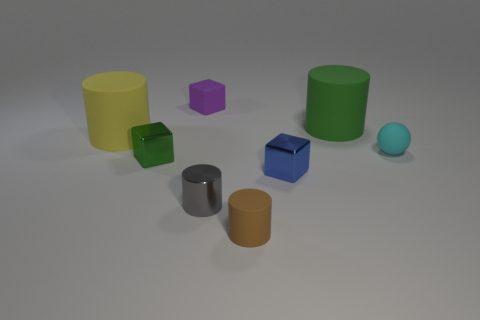There is a large object that is on the left side of the tiny matte thing that is behind the big green cylinder; what is its shape?
Keep it short and to the point. Cylinder. The green matte thing is what size?
Make the answer very short. Large. The brown matte thing is what shape?
Your answer should be compact. Cylinder. There is a tiny gray thing; is its shape the same as the green thing to the right of the tiny green thing?
Provide a short and direct response. Yes. Does the metal object in front of the small blue object have the same shape as the tiny purple object?
Offer a very short reply. No. How many cylinders are behind the small brown object and in front of the green metal cube?
Make the answer very short. 1. What number of other things are there of the same size as the gray thing?
Provide a succinct answer. 5. Are there an equal number of large yellow things behind the tiny blue shiny block and tiny green metal objects?
Your answer should be compact. Yes. There is a metallic block that is on the left side of the gray object; is it the same color as the rubber object that is in front of the cyan ball?
Your response must be concise. No. There is a block that is both behind the blue thing and in front of the large green object; what is it made of?
Your answer should be very brief. Metal. 